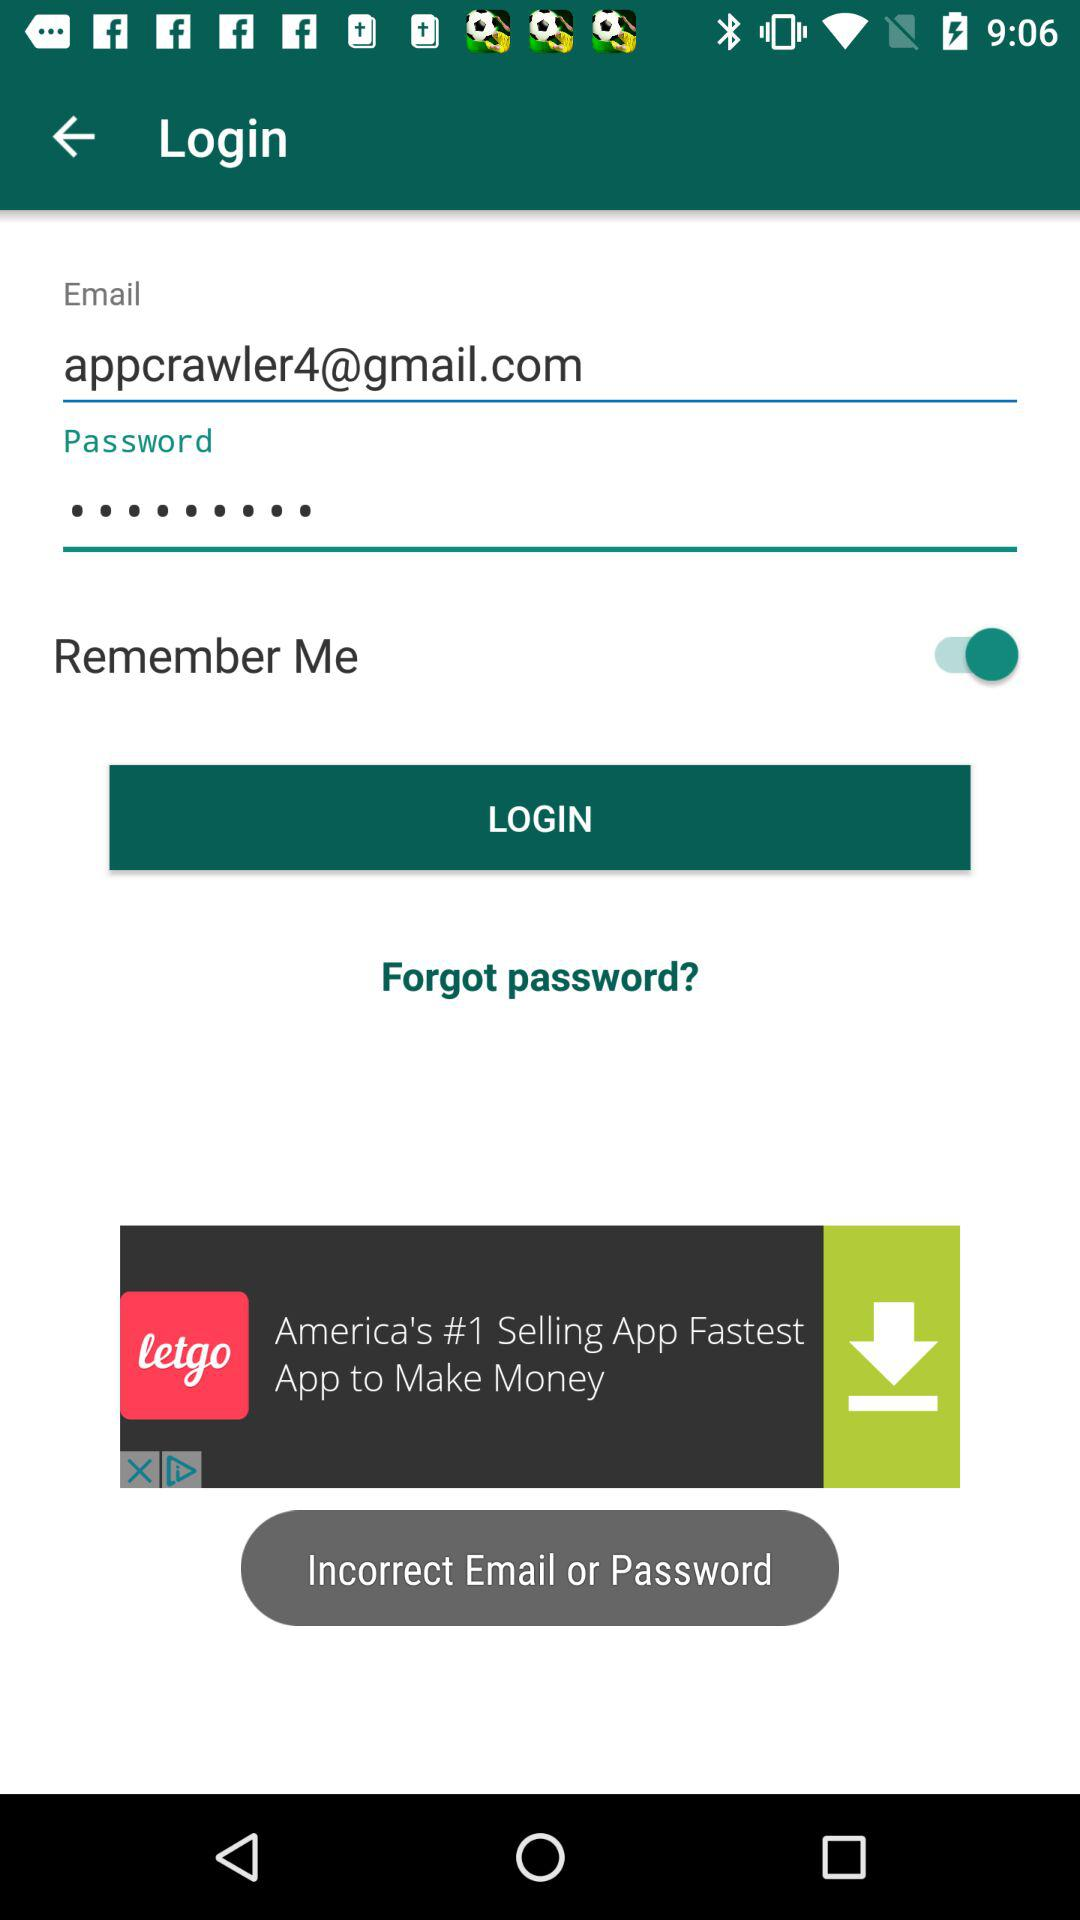What is the email address? The email address is appcrawler4@gmail.com. 